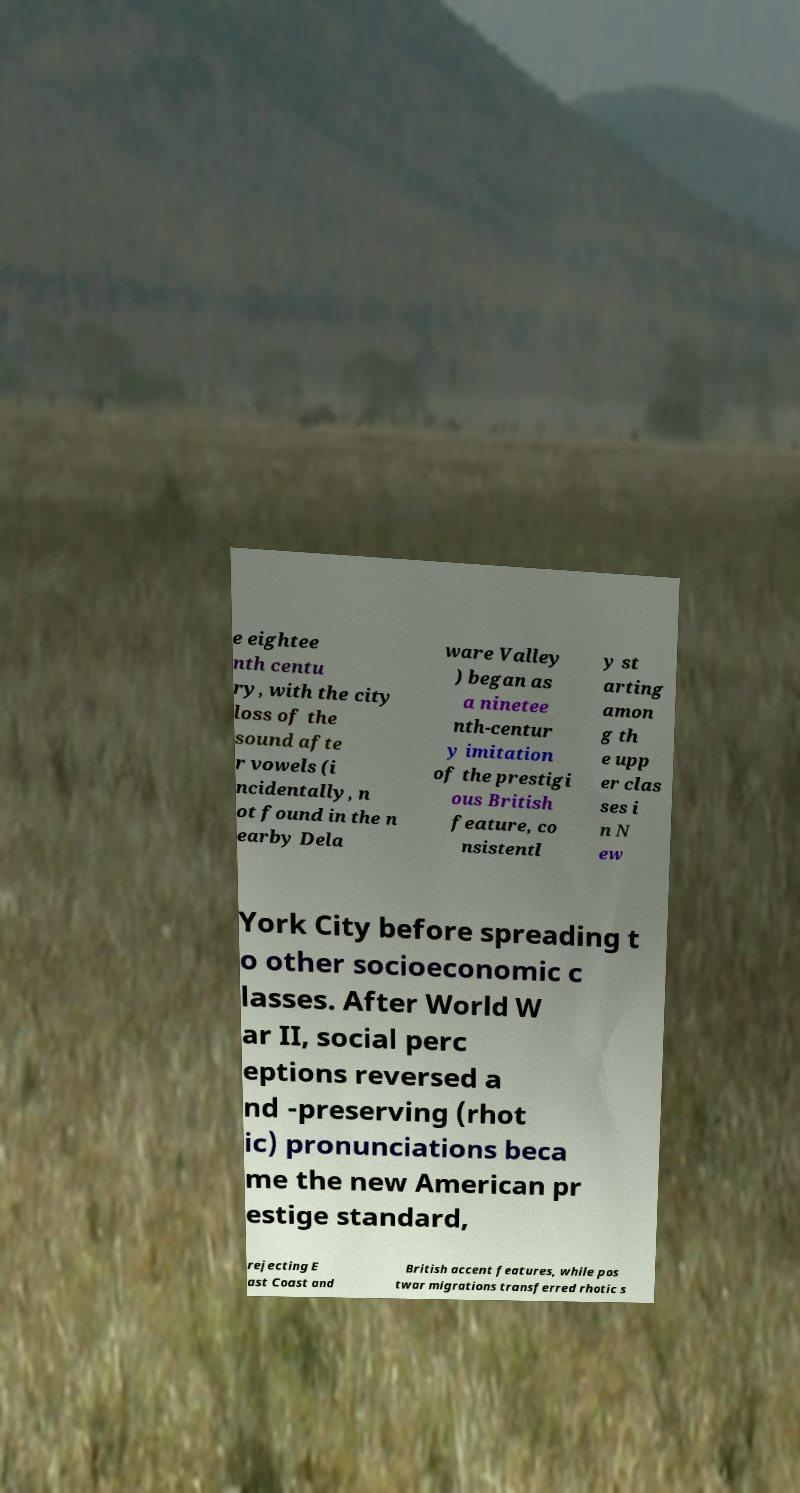Can you accurately transcribe the text from the provided image for me? e eightee nth centu ry, with the city loss of the sound afte r vowels (i ncidentally, n ot found in the n earby Dela ware Valley ) began as a ninetee nth-centur y imitation of the prestigi ous British feature, co nsistentl y st arting amon g th e upp er clas ses i n N ew York City before spreading t o other socioeconomic c lasses. After World W ar II, social perc eptions reversed a nd -preserving (rhot ic) pronunciations beca me the new American pr estige standard, rejecting E ast Coast and British accent features, while pos twar migrations transferred rhotic s 